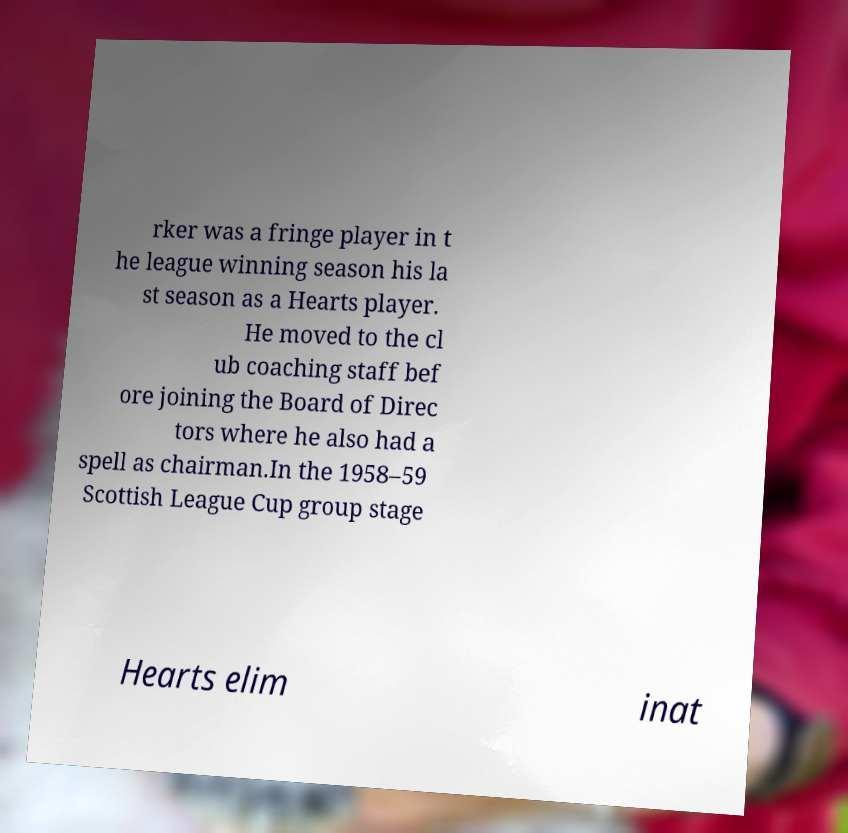Please read and relay the text visible in this image. What does it say? rker was a fringe player in t he league winning season his la st season as a Hearts player. He moved to the cl ub coaching staff bef ore joining the Board of Direc tors where he also had a spell as chairman.In the 1958–59 Scottish League Cup group stage Hearts elim inat 